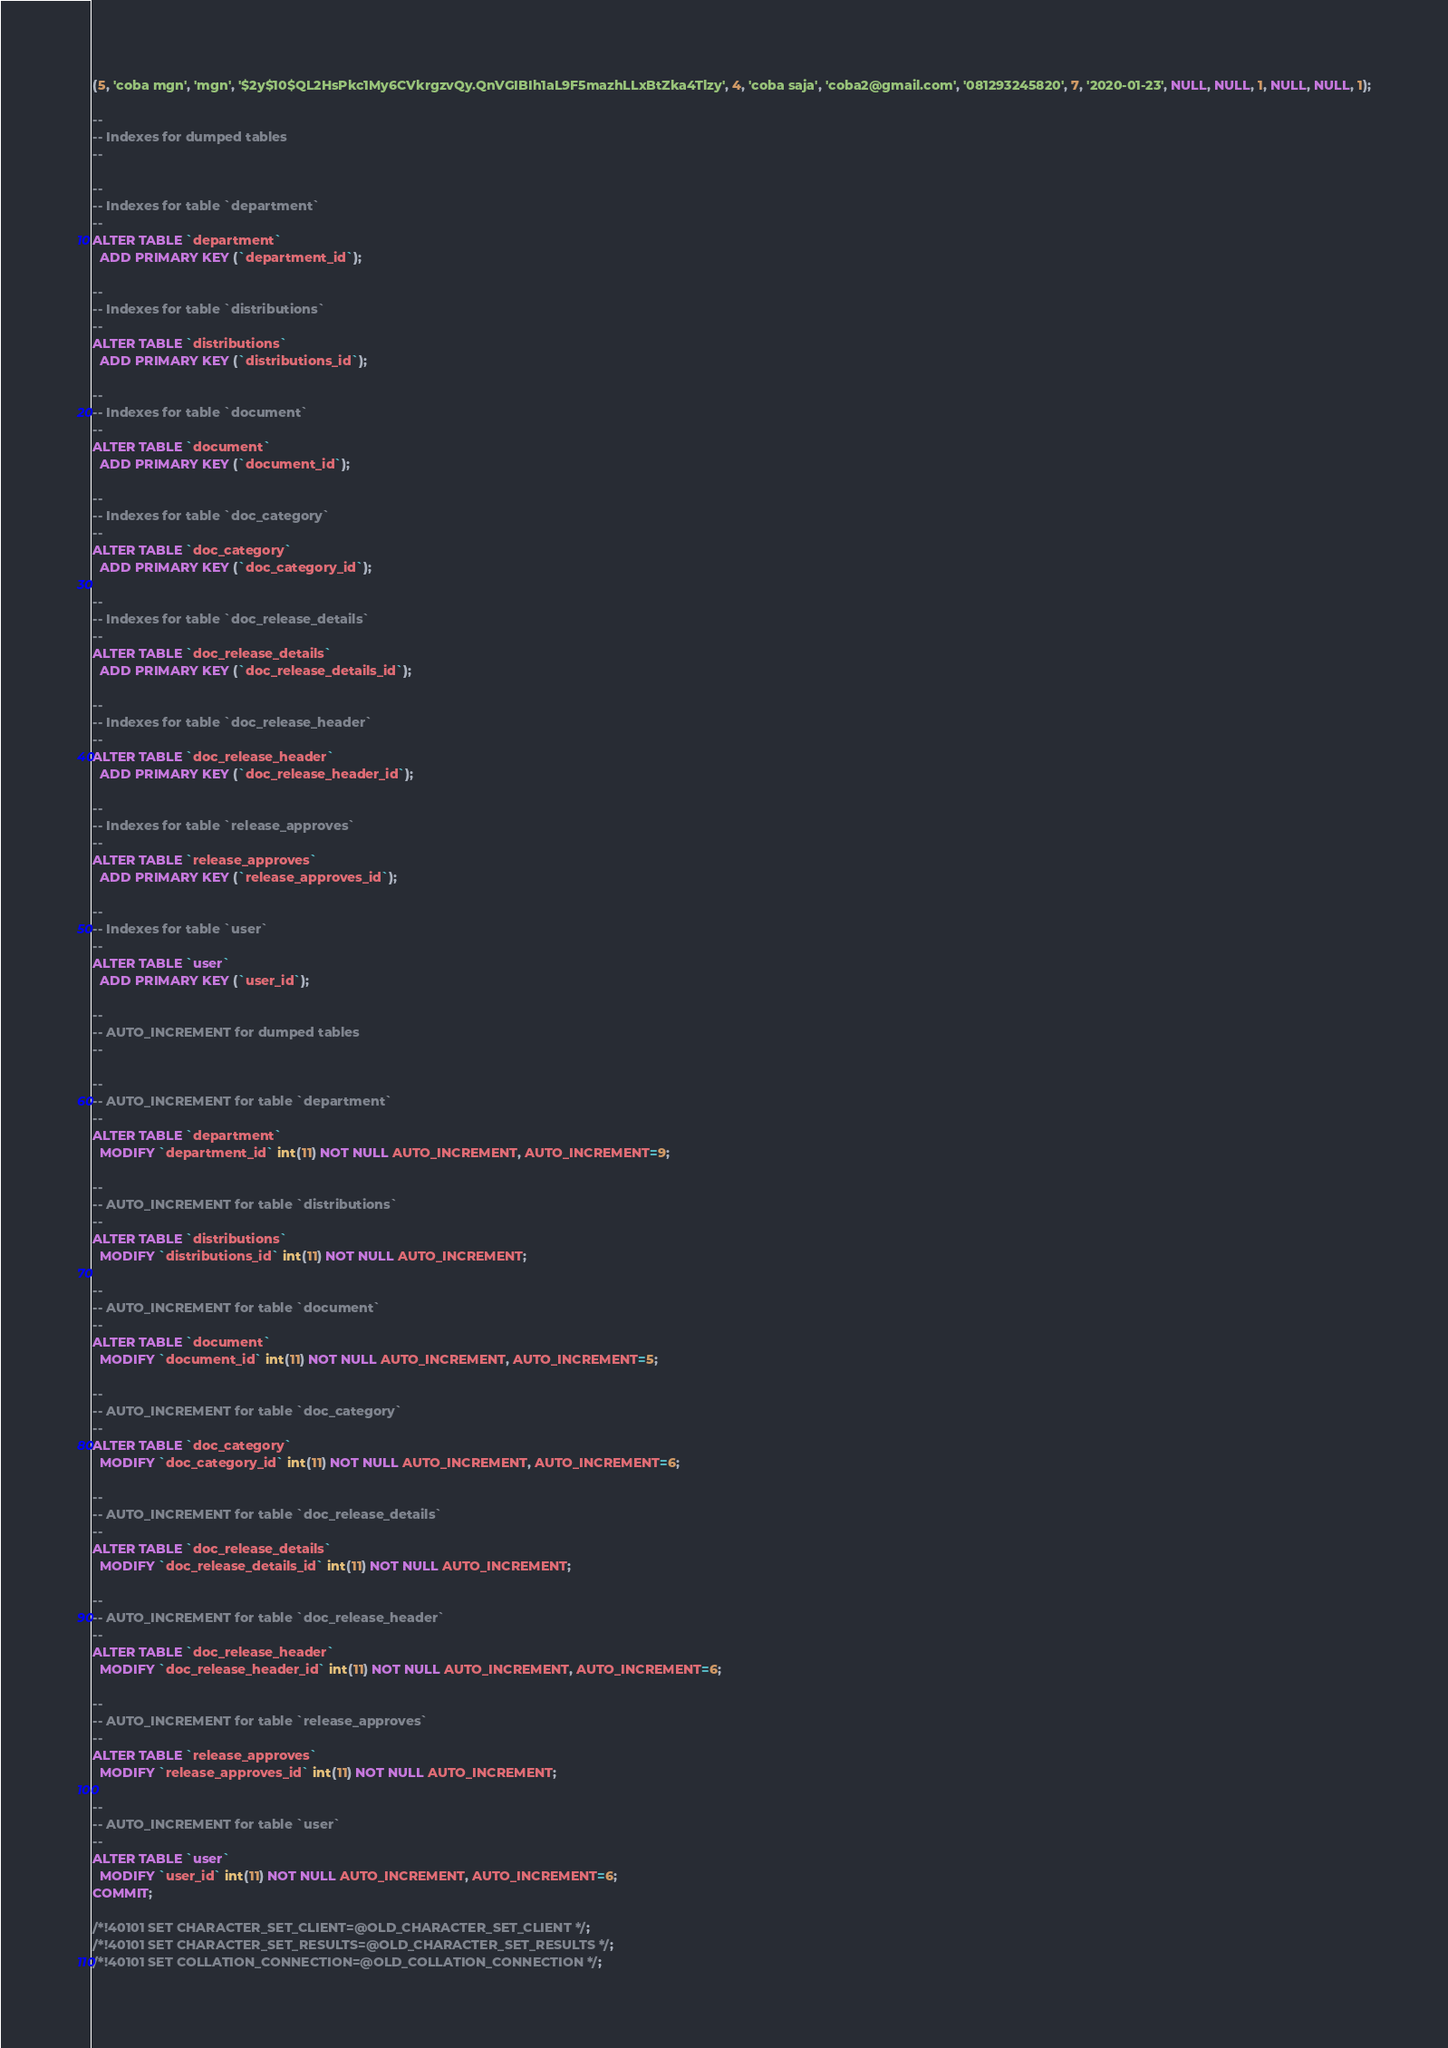Convert code to text. <code><loc_0><loc_0><loc_500><loc_500><_SQL_>(5, 'coba mgn', 'mgn', '$2y$10$QL2HsPkc1My6CVkrgzvQy.QnVGIBIh1aL9F5mazhLLxBtZka4Tlzy', 4, 'coba saja', 'coba2@gmail.com', '081293245820', 7, '2020-01-23', NULL, NULL, 1, NULL, NULL, 1);

--
-- Indexes for dumped tables
--

--
-- Indexes for table `department`
--
ALTER TABLE `department`
  ADD PRIMARY KEY (`department_id`);

--
-- Indexes for table `distributions`
--
ALTER TABLE `distributions`
  ADD PRIMARY KEY (`distributions_id`);

--
-- Indexes for table `document`
--
ALTER TABLE `document`
  ADD PRIMARY KEY (`document_id`);

--
-- Indexes for table `doc_category`
--
ALTER TABLE `doc_category`
  ADD PRIMARY KEY (`doc_category_id`);

--
-- Indexes for table `doc_release_details`
--
ALTER TABLE `doc_release_details`
  ADD PRIMARY KEY (`doc_release_details_id`);

--
-- Indexes for table `doc_release_header`
--
ALTER TABLE `doc_release_header`
  ADD PRIMARY KEY (`doc_release_header_id`);

--
-- Indexes for table `release_approves`
--
ALTER TABLE `release_approves`
  ADD PRIMARY KEY (`release_approves_id`);

--
-- Indexes for table `user`
--
ALTER TABLE `user`
  ADD PRIMARY KEY (`user_id`);

--
-- AUTO_INCREMENT for dumped tables
--

--
-- AUTO_INCREMENT for table `department`
--
ALTER TABLE `department`
  MODIFY `department_id` int(11) NOT NULL AUTO_INCREMENT, AUTO_INCREMENT=9;

--
-- AUTO_INCREMENT for table `distributions`
--
ALTER TABLE `distributions`
  MODIFY `distributions_id` int(11) NOT NULL AUTO_INCREMENT;

--
-- AUTO_INCREMENT for table `document`
--
ALTER TABLE `document`
  MODIFY `document_id` int(11) NOT NULL AUTO_INCREMENT, AUTO_INCREMENT=5;

--
-- AUTO_INCREMENT for table `doc_category`
--
ALTER TABLE `doc_category`
  MODIFY `doc_category_id` int(11) NOT NULL AUTO_INCREMENT, AUTO_INCREMENT=6;

--
-- AUTO_INCREMENT for table `doc_release_details`
--
ALTER TABLE `doc_release_details`
  MODIFY `doc_release_details_id` int(11) NOT NULL AUTO_INCREMENT;

--
-- AUTO_INCREMENT for table `doc_release_header`
--
ALTER TABLE `doc_release_header`
  MODIFY `doc_release_header_id` int(11) NOT NULL AUTO_INCREMENT, AUTO_INCREMENT=6;

--
-- AUTO_INCREMENT for table `release_approves`
--
ALTER TABLE `release_approves`
  MODIFY `release_approves_id` int(11) NOT NULL AUTO_INCREMENT;

--
-- AUTO_INCREMENT for table `user`
--
ALTER TABLE `user`
  MODIFY `user_id` int(11) NOT NULL AUTO_INCREMENT, AUTO_INCREMENT=6;
COMMIT;

/*!40101 SET CHARACTER_SET_CLIENT=@OLD_CHARACTER_SET_CLIENT */;
/*!40101 SET CHARACTER_SET_RESULTS=@OLD_CHARACTER_SET_RESULTS */;
/*!40101 SET COLLATION_CONNECTION=@OLD_COLLATION_CONNECTION */;
</code> 